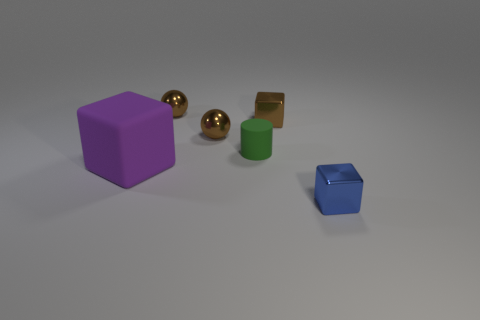Add 2 tiny balls. How many objects exist? 8 Subtract all cylinders. How many objects are left? 5 Add 6 small brown rubber cylinders. How many small brown rubber cylinders exist? 6 Subtract 0 gray blocks. How many objects are left? 6 Subtract all spheres. Subtract all large rubber blocks. How many objects are left? 3 Add 4 small blue metal blocks. How many small blue metal blocks are left? 5 